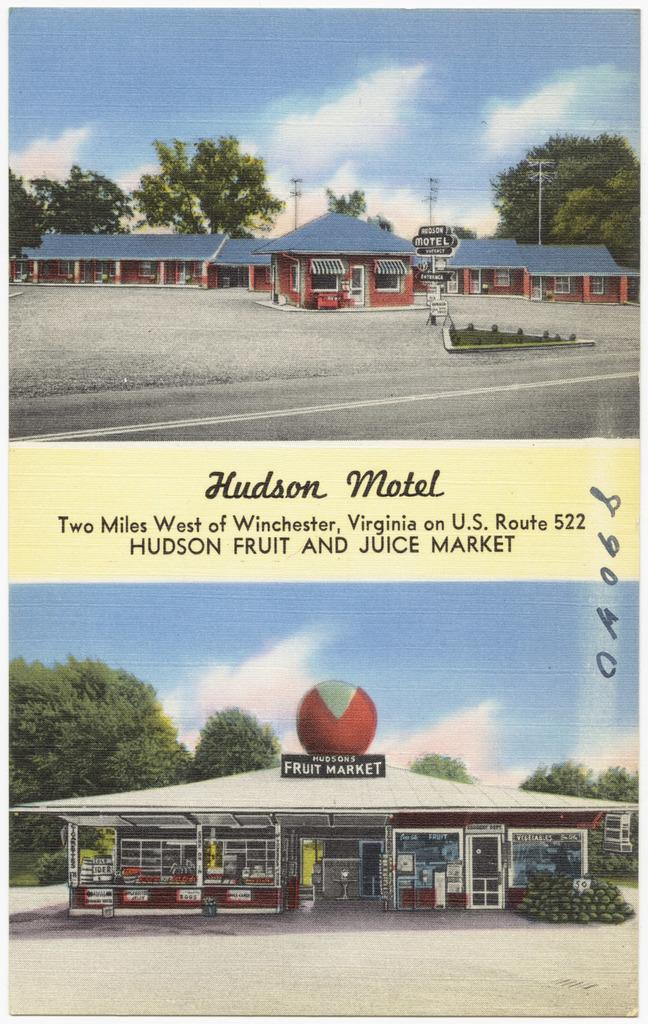What is the main subject of the poster in the image? The poster contains images of houses, boards, trees, the sky with clouds, and poles. What type of text is present on the poster? The poster contains text. What type of weather can be seen in the image? There is no weather depicted in the image, as it is a poster with images and text. What type of suit is being worn by the person in the image? There is no person present in the image, only a poster with images and text. 